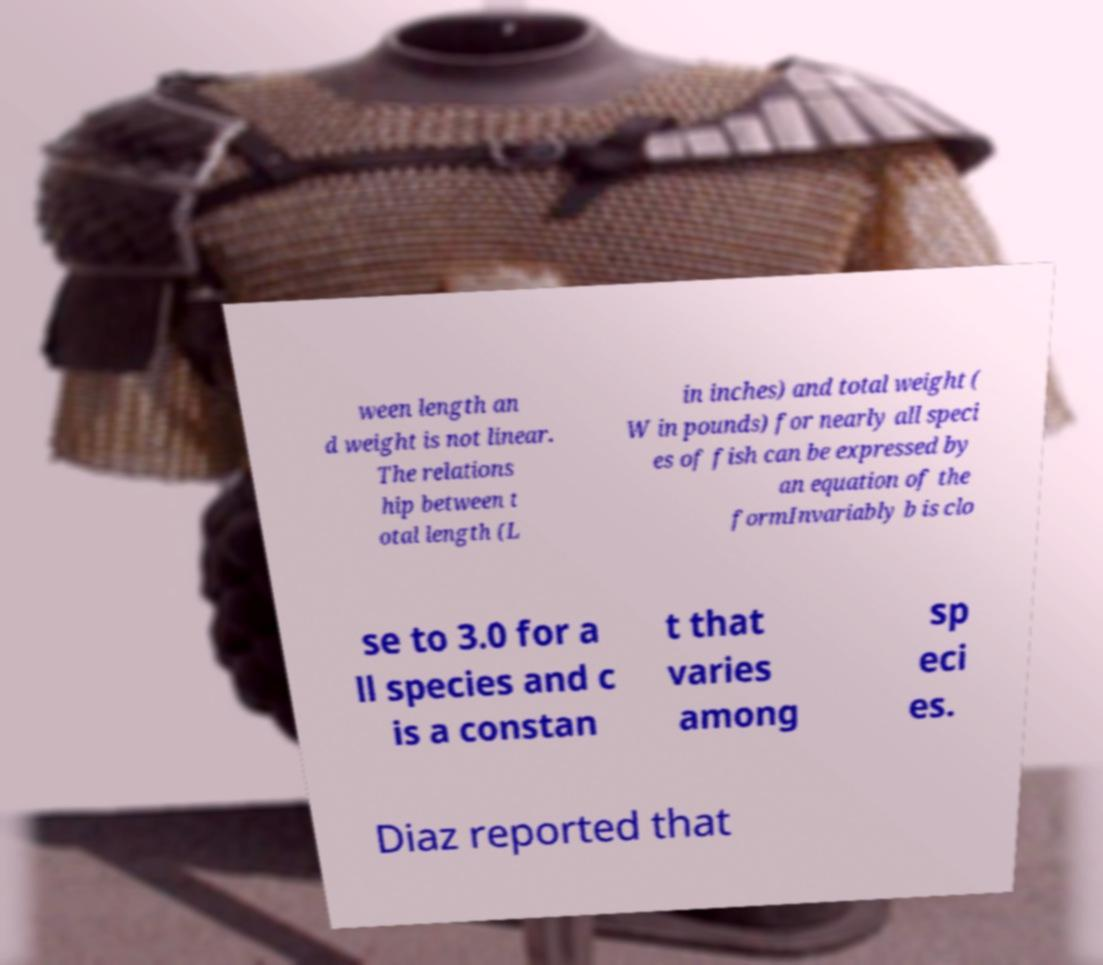Please identify and transcribe the text found in this image. ween length an d weight is not linear. The relations hip between t otal length (L in inches) and total weight ( W in pounds) for nearly all speci es of fish can be expressed by an equation of the formInvariably b is clo se to 3.0 for a ll species and c is a constan t that varies among sp eci es. Diaz reported that 